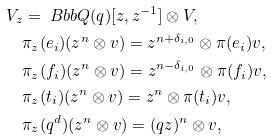<formula> <loc_0><loc_0><loc_500><loc_500>& V _ { z } = { \ B b b Q } ( q ) [ z , z ^ { - 1 } ] \otimes V , \\ & \quad \pi _ { z } ( e _ { i } ) ( z ^ { n } \otimes v ) = z ^ { n + \delta _ { i , 0 } } \otimes \pi ( e _ { i } ) v , \\ & \quad \pi _ { z } ( f _ { i } ) ( z ^ { n } \otimes v ) = z ^ { n - \delta _ { i , 0 } } \otimes \pi ( f _ { i } ) v , \\ & \quad \pi _ { z } ( t _ { i } ) ( z ^ { n } \otimes v ) = z ^ { n } \otimes \pi ( t _ { i } ) v , \\ & \quad \pi _ { z } ( q ^ { d } ) ( z ^ { n } \otimes v ) = ( q z ) ^ { n } \otimes v ,</formula> 